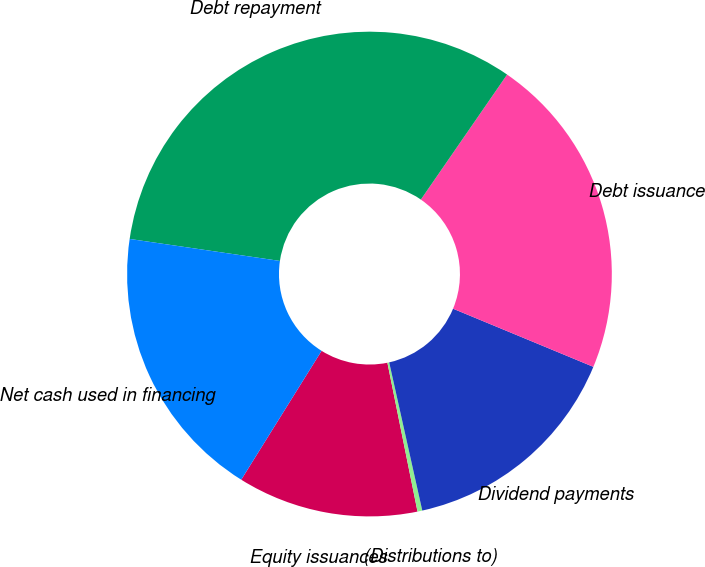<chart> <loc_0><loc_0><loc_500><loc_500><pie_chart><fcel>Equity issuances<fcel>(Distributions to)<fcel>Dividend payments<fcel>Debt issuance<fcel>Debt repayment<fcel>Net cash used in financing<nl><fcel>12.05%<fcel>0.32%<fcel>15.25%<fcel>21.64%<fcel>32.3%<fcel>18.44%<nl></chart> 